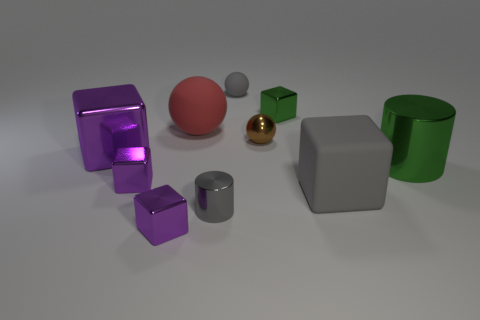Does the gray sphere right of the red matte sphere have the same size as the big red rubber sphere?
Provide a succinct answer. No. Is the number of large red spheres less than the number of tiny yellow spheres?
Give a very brief answer. No. Are there any small things that have the same material as the large red thing?
Ensure brevity in your answer.  Yes. There is a gray object that is behind the brown metallic object; what shape is it?
Ensure brevity in your answer.  Sphere. There is a small metallic block that is on the right side of the tiny gray matte thing; is it the same color as the large cylinder?
Give a very brief answer. Yes. Are there fewer green cylinders that are to the left of the tiny brown sphere than gray matte things?
Ensure brevity in your answer.  Yes. What color is the small cylinder that is the same material as the tiny green block?
Ensure brevity in your answer.  Gray. There is a thing that is in front of the gray cylinder; how big is it?
Give a very brief answer. Small. Are the gray sphere and the big red sphere made of the same material?
Your answer should be compact. Yes. Are there any green shiny cylinders that are in front of the purple cube that is in front of the large block that is to the right of the small metal cylinder?
Make the answer very short. No. 